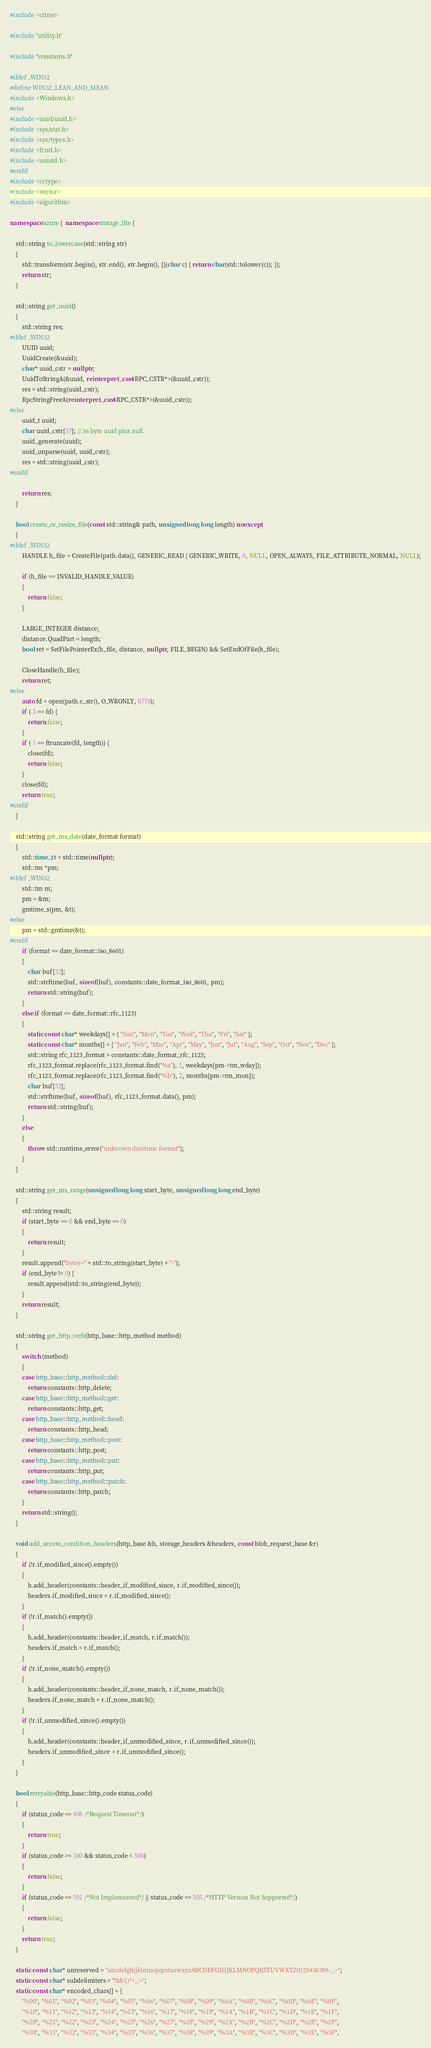Convert code to text. <code><loc_0><loc_0><loc_500><loc_500><_C++_>#include <ctime>

#include "utility.h"

#include "constants.h"

#ifdef _WIN32
#define WIN32_LEAN_AND_MEAN
#include <Windows.h>
#else
#include <uuid/uuid.h>
#include <sys/stat.h>
#include <sys/types.h>
#include <fcntl.h>
#include <unistd.h>
#endif
#include <cctype>
#include <vector>
#include <algorithm>

namespace azure {  namespace storage_lite {

    std::string to_lowercase(std::string str)
    {
        std::transform(str.begin(), str.end(), str.begin(), [](char c) { return char(std::tolower(c)); });
        return str;
    }

    std::string get_uuid()
    {
        std::string res;
#ifdef _WIN32
        UUID uuid;
        UuidCreate(&uuid);
        char* uuid_cstr = nullptr;
        UuidToStringA(&uuid, reinterpret_cast<RPC_CSTR*>(&uuid_cstr));
        res = std::string(uuid_cstr);
        RpcStringFreeA(reinterpret_cast<RPC_CSTR*>(&uuid_cstr));
#else
        uuid_t uuid;
        char uuid_cstr[37]; // 36 byte uuid plus null.
        uuid_generate(uuid);
        uuid_unparse(uuid, uuid_cstr);
        res = std::string(uuid_cstr);
#endif

        return res;
    }

    bool create_or_resize_file(const std::string& path, unsigned long long length) noexcept
    {
#ifdef _WIN32
        HANDLE h_file = CreateFile(path.data(), GENERIC_READ | GENERIC_WRITE, 0, NULL, OPEN_ALWAYS, FILE_ATTRIBUTE_NORMAL, NULL);

        if (h_file == INVALID_HANDLE_VALUE)
        {
            return false;
        }

        LARGE_INTEGER distance;
        distance.QuadPart = length;
        bool ret = SetFilePointerEx(h_file, distance, nullptr, FILE_BEGIN) && SetEndOfFile(h_file);

        CloseHandle(h_file);
        return ret;
#else
        auto fd = open(path.c_str(), O_WRONLY, 0770);
        if (-1 == fd) {
            return false;
        }
        if (-1 == ftruncate(fd, length)) {
            close(fd);
            return false;
        }
        close(fd);
        return true;
#endif
    }

    std::string get_ms_date(date_format format)
    {
        std::time_t t = std::time(nullptr);
        std::tm *pm;
#ifdef _WIN32
        std::tm m;
        pm = &m;
        gmtime_s(pm, &t);
#else
        pm = std::gmtime(&t);
#endif
        if (format == date_format::iso_8601)
        {
            char buf[32];
            std::strftime(buf, sizeof(buf), constants::date_format_iso_8601, pm);
            return std::string(buf);
        }
        else if (format == date_format::rfc_1123)
        {
            static const char* weekdays[] = { "Sun", "Mon", "Tue", "Wed", "Thu", "Fri", "Sat" };
            static const char* months[] = { "Jan", "Feb", "Mar", "Apr", "May", "Jun", "Jul", "Aug", "Sep", "Oct", "Nov", "Dec" };
            std::string rfc_1123_format = constants::date_format_rfc_1123;
            rfc_1123_format.replace(rfc_1123_format.find("%a"), 2, weekdays[pm->tm_wday]);
            rfc_1123_format.replace(rfc_1123_format.find("%b"), 2, months[pm->tm_mon]);
            char buf[32];
            std::strftime(buf, sizeof(buf), rfc_1123_format.data(), pm);
            return std::string(buf);
        }
        else
        {
            throw std::runtime_error("unknown datetime format");
        }
    }

    std::string get_ms_range(unsigned long long start_byte, unsigned long long end_byte)
    {
        std::string result;
        if (start_byte == 0 && end_byte == 0)
        {
            return result;
        }
        result.append("bytes=" + std::to_string(start_byte) + "-");
        if (end_byte != 0) {
            result.append(std::to_string(end_byte));
        }
        return result;
    }

    std::string get_http_verb(http_base::http_method method)
    {
        switch (method)
        {
        case http_base::http_method::del:
            return constants::http_delete;
        case http_base::http_method::get:
            return constants::http_get;
        case http_base::http_method::head:
            return constants::http_head;
        case http_base::http_method::post:
            return constants::http_post;
        case http_base::http_method::put:
            return constants::http_put;
        case http_base::http_method::patch:
            return constants::http_patch;
        }
        return std::string();
    }

    void add_access_condition_headers(http_base &h, storage_headers &headers, const blob_request_base &r)
    {
        if (!r.if_modified_since().empty())
        {
            h.add_header(constants::header_if_modified_since, r.if_modified_since());
            headers.if_modified_since = r.if_modified_since();
        }
        if (!r.if_match().empty())
        {
            h.add_header(constants::header_if_match, r.if_match());
            headers.if_match = r.if_match();
        }
        if (!r.if_none_match().empty())
        {
            h.add_header(constants::header_if_none_match, r.if_none_match());
            headers.if_none_match = r.if_none_match();
        }
        if (!r.if_unmodified_since().empty())
        {
            h.add_header(constants::header_if_unmodified_since, r.if_unmodified_since());
            headers.if_unmodified_since = r.if_unmodified_since();
        }
    }

    bool retryable(http_base::http_code status_code)
    {
        if (status_code == 408 /*Request Timeout*/)
        {
            return true;
        }
        if (status_code >= 300 && status_code < 500)
        {
            return false;
        }
        if (status_code == 501 /*Not Implemented*/ || status_code == 505 /*HTTP Version Not Supported*/)
        {
            return false;
        }
        return true;
    }

    static const char* unreserved = "abcdefghijklmnopqrstuvwxyzABCDEFGHIJKLMNOPQRSTUVWXYZ0123456789-._~";
    static const char* subdelimiters = "!$&'()*+,;=";
    static const char* encoded_chars[] = {
        "%00", "%01", "%02", "%03", "%04", "%05", "%06", "%07", "%08", "%09", "%0A", "%0B", "%0C", "%0D", "%0E", "%0F",
        "%10", "%11", "%12", "%13", "%14", "%15", "%16", "%17", "%18", "%19", "%1A", "%1B", "%1C", "%1D", "%1E", "%1F",
        "%20", "%21", "%22", "%23", "%24", "%25", "%26", "%27", "%28", "%29", "%2A", "%2B", "%2C", "%2D", "%2E", "%2F",
        "%30", "%31", "%32", "%33", "%34", "%35", "%36", "%37", "%38", "%39", "%3A", "%3B", "%3C", "%3D", "%3E", "%3F",</code> 